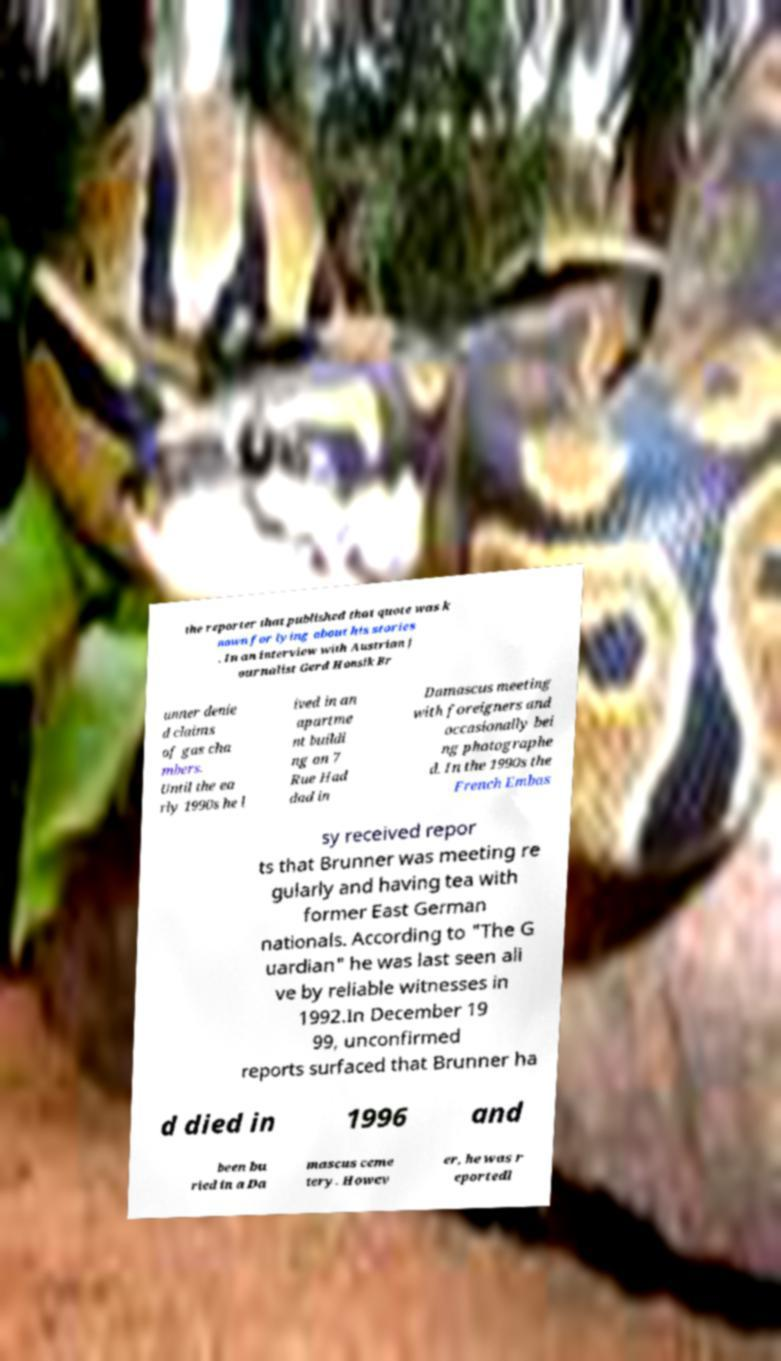What messages or text are displayed in this image? I need them in a readable, typed format. the reporter that published that quote was k nown for lying about his stories . In an interview with Austrian j ournalist Gerd Honsik Br unner denie d claims of gas cha mbers. Until the ea rly 1990s he l ived in an apartme nt buildi ng on 7 Rue Had dad in Damascus meeting with foreigners and occasionally bei ng photographe d. In the 1990s the French Embas sy received repor ts that Brunner was meeting re gularly and having tea with former East German nationals. According to "The G uardian" he was last seen ali ve by reliable witnesses in 1992.In December 19 99, unconfirmed reports surfaced that Brunner ha d died in 1996 and been bu ried in a Da mascus ceme tery. Howev er, he was r eportedl 